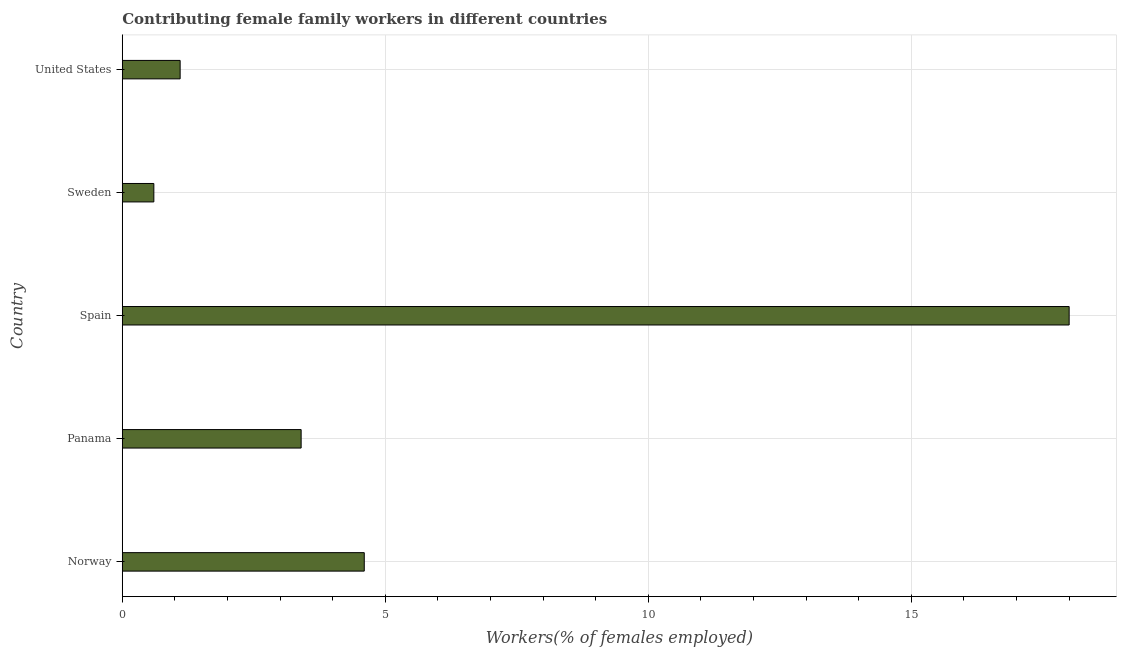Does the graph contain any zero values?
Make the answer very short. No. What is the title of the graph?
Keep it short and to the point. Contributing female family workers in different countries. What is the label or title of the X-axis?
Keep it short and to the point. Workers(% of females employed). What is the contributing female family workers in Panama?
Your response must be concise. 3.4. Across all countries, what is the minimum contributing female family workers?
Offer a very short reply. 0.6. In which country was the contributing female family workers maximum?
Your answer should be compact. Spain. In which country was the contributing female family workers minimum?
Keep it short and to the point. Sweden. What is the sum of the contributing female family workers?
Your answer should be compact. 27.7. What is the difference between the contributing female family workers in Spain and Sweden?
Make the answer very short. 17.4. What is the average contributing female family workers per country?
Keep it short and to the point. 5.54. What is the median contributing female family workers?
Offer a very short reply. 3.4. In how many countries, is the contributing female family workers greater than 3 %?
Ensure brevity in your answer.  3. Is the contributing female family workers in Panama less than that in Sweden?
Your response must be concise. No. Is the difference between the contributing female family workers in Sweden and United States greater than the difference between any two countries?
Your answer should be very brief. No. How many bars are there?
Offer a terse response. 5. How many countries are there in the graph?
Your answer should be very brief. 5. What is the difference between two consecutive major ticks on the X-axis?
Offer a very short reply. 5. What is the Workers(% of females employed) of Norway?
Keep it short and to the point. 4.6. What is the Workers(% of females employed) of Panama?
Offer a terse response. 3.4. What is the Workers(% of females employed) of Spain?
Offer a very short reply. 18. What is the Workers(% of females employed) of Sweden?
Offer a very short reply. 0.6. What is the Workers(% of females employed) in United States?
Keep it short and to the point. 1.1. What is the difference between the Workers(% of females employed) in Norway and Panama?
Provide a succinct answer. 1.2. What is the difference between the Workers(% of females employed) in Norway and Spain?
Keep it short and to the point. -13.4. What is the difference between the Workers(% of females employed) in Panama and Spain?
Offer a terse response. -14.6. What is the difference between the Workers(% of females employed) in Panama and United States?
Offer a terse response. 2.3. What is the difference between the Workers(% of females employed) in Sweden and United States?
Your response must be concise. -0.5. What is the ratio of the Workers(% of females employed) in Norway to that in Panama?
Provide a short and direct response. 1.35. What is the ratio of the Workers(% of females employed) in Norway to that in Spain?
Keep it short and to the point. 0.26. What is the ratio of the Workers(% of females employed) in Norway to that in Sweden?
Give a very brief answer. 7.67. What is the ratio of the Workers(% of females employed) in Norway to that in United States?
Your response must be concise. 4.18. What is the ratio of the Workers(% of females employed) in Panama to that in Spain?
Provide a succinct answer. 0.19. What is the ratio of the Workers(% of females employed) in Panama to that in Sweden?
Provide a succinct answer. 5.67. What is the ratio of the Workers(% of females employed) in Panama to that in United States?
Your answer should be very brief. 3.09. What is the ratio of the Workers(% of females employed) in Spain to that in Sweden?
Provide a succinct answer. 30. What is the ratio of the Workers(% of females employed) in Spain to that in United States?
Provide a short and direct response. 16.36. What is the ratio of the Workers(% of females employed) in Sweden to that in United States?
Offer a terse response. 0.55. 